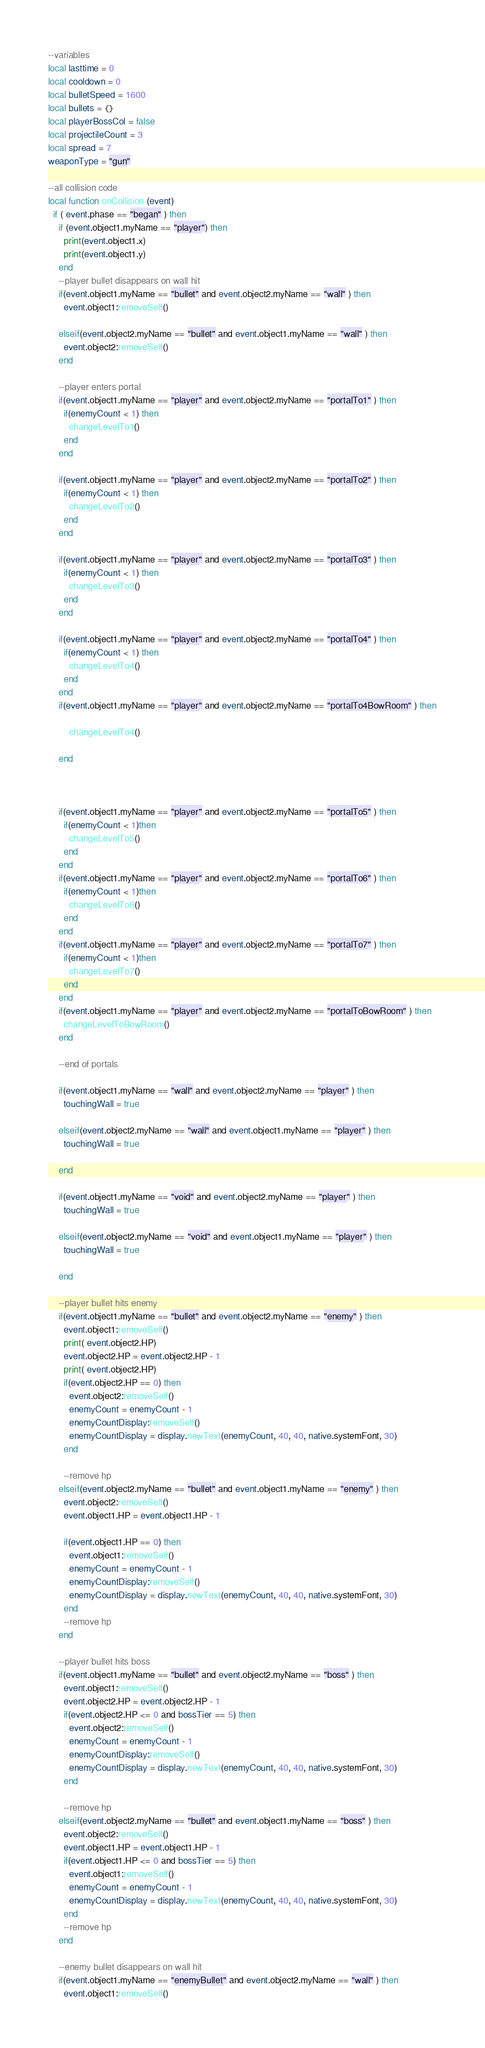Convert code to text. <code><loc_0><loc_0><loc_500><loc_500><_Lua_>--variables
local lasttime = 0
local cooldown = 0
local bulletSpeed = 1600
local bullets = {}
local playerBossCol = false
local projectileCount = 3
local spread = 7
weaponType = "gun"

--all collision code
local function onCollision (event)
  if ( event.phase == "began" ) then
    if (event.object1.myName == "player") then
      print(event.object1.x)
      print(event.object1.y)
    end
    --player bullet disappears on wall hit
    if(event.object1.myName == "bullet" and event.object2.myName == "wall" ) then
      event.object1:removeSelf()

    elseif(event.object2.myName == "bullet" and event.object1.myName == "wall" ) then
      event.object2:removeSelf()
    end

    --player enters portal
    if(event.object1.myName == "player" and event.object2.myName == "portalTo1" ) then
      if(enemyCount < 1) then
        changeLevelTo1()
      end
    end

    if(event.object1.myName == "player" and event.object2.myName == "portalTo2" ) then
      if(enemyCount < 1) then
        changeLevelTo2()
      end
    end

    if(event.object1.myName == "player" and event.object2.myName == "portalTo3" ) then
      if(enemyCount < 1) then
        changeLevelTo3()
      end
    end

    if(event.object1.myName == "player" and event.object2.myName == "portalTo4" ) then
      if(enemyCount < 1) then
        changeLevelTo4()
      end
    end
    if(event.object1.myName == "player" and event.object2.myName == "portalTo4BowRoom" ) then
    
        changeLevelTo4()

    end



    if(event.object1.myName == "player" and event.object2.myName == "portalTo5" ) then
      if(enemyCount < 1)then
        changeLevelTo5()
      end
    end
    if(event.object1.myName == "player" and event.object2.myName == "portalTo6" ) then
      if(enemyCount < 1)then
        changeLevelTo6()
      end
    end
    if(event.object1.myName == "player" and event.object2.myName == "portalTo7" ) then
      if(enemyCount < 1)then
        changeLevelTo7()
      end
    end
    if(event.object1.myName == "player" and event.object2.myName == "portalToBowRoom" ) then
      changeLevelToBowRoom()
    end

    --end of portals

    if(event.object1.myName == "wall" and event.object2.myName == "player" ) then
      touchingWall = true

    elseif(event.object2.myName == "wall" and event.object1.myName == "player" ) then
      touchingWall = true

    end

    if(event.object1.myName == "void" and event.object2.myName == "player" ) then
      touchingWall = true

    elseif(event.object2.myName == "void" and event.object1.myName == "player" ) then
      touchingWall = true

    end

    --player bullet hits enemy
    if(event.object1.myName == "bullet" and event.object2.myName == "enemy" ) then
      event.object1:removeSelf()
      print( event.object2.HP)
      event.object2.HP = event.object2.HP - 1
      print( event.object2.HP)
      if(event.object2.HP == 0) then
        event.object2:removeSelf()
        enemyCount = enemyCount - 1
        enemyCountDisplay:removeSelf()
        enemyCountDisplay = display.newText(enemyCount, 40, 40, native.systemFont, 30)
      end

      --remove hp
    elseif(event.object2.myName == "bullet" and event.object1.myName == "enemy" ) then
      event.object2:removeSelf()
      event.object1.HP = event.object1.HP - 1

      if(event.object1.HP == 0) then
        event.object1:removeSelf()
        enemyCount = enemyCount - 1
        enemyCountDisplay:removeSelf()
        enemyCountDisplay = display.newText(enemyCount, 40, 40, native.systemFont, 30)
      end
      --remove hp
    end

    --player bullet hits boss
    if(event.object1.myName == "bullet" and event.object2.myName == "boss" ) then
      event.object1:removeSelf()
      event.object2.HP = event.object2.HP - 1
      if(event.object2.HP <= 0 and bossTier == 5) then
        event.object2:removeSelf()
        enemyCount = enemyCount - 1
        enemyCountDisplay:removeSelf()
        enemyCountDisplay = display.newText(enemyCount, 40, 40, native.systemFont, 30)
      end

      --remove hp
    elseif(event.object2.myName == "bullet" and event.object1.myName == "boss" ) then
      event.object2:removeSelf()
      event.object1.HP = event.object1.HP - 1
      if(event.object1.HP <= 0 and bossTier == 5) then
        event.object1:removeSelf()
        enemyCount = enemyCount - 1
        enemyCountDisplay = display.newText(enemyCount, 40, 40, native.systemFont, 30)
      end
      --remove hp
    end

    --enemy bullet disappears on wall hit
    if(event.object1.myName == "enemyBullet" and event.object2.myName == "wall" ) then
      event.object1:removeSelf()</code> 